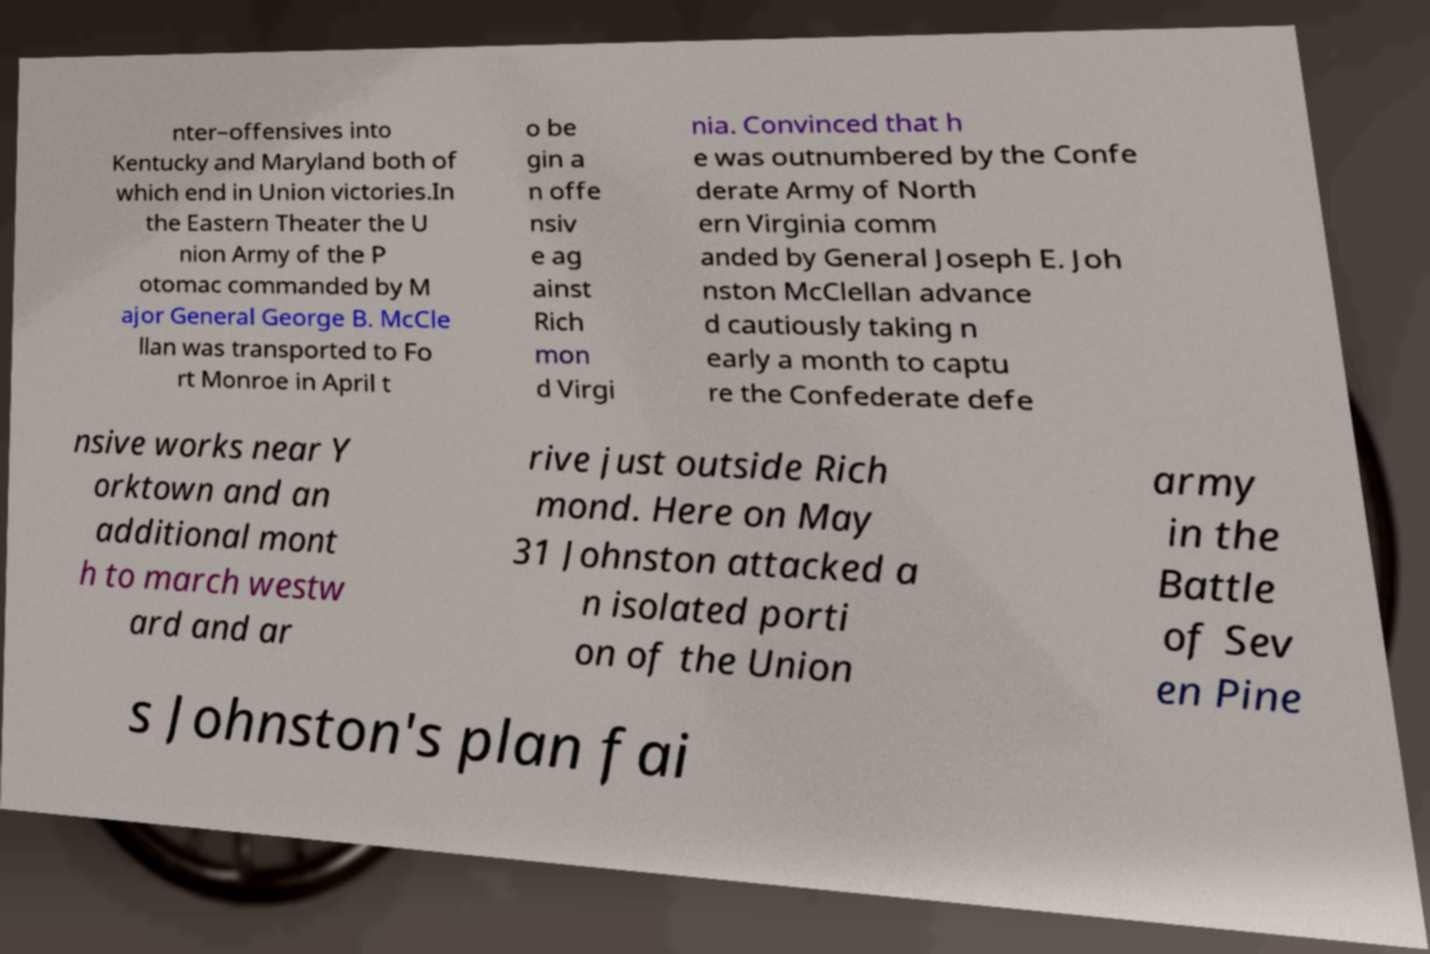What messages or text are displayed in this image? I need them in a readable, typed format. nter–offensives into Kentucky and Maryland both of which end in Union victories.In the Eastern Theater the U nion Army of the P otomac commanded by M ajor General George B. McCle llan was transported to Fo rt Monroe in April t o be gin a n offe nsiv e ag ainst Rich mon d Virgi nia. Convinced that h e was outnumbered by the Confe derate Army of North ern Virginia comm anded by General Joseph E. Joh nston McClellan advance d cautiously taking n early a month to captu re the Confederate defe nsive works near Y orktown and an additional mont h to march westw ard and ar rive just outside Rich mond. Here on May 31 Johnston attacked a n isolated porti on of the Union army in the Battle of Sev en Pine s Johnston's plan fai 